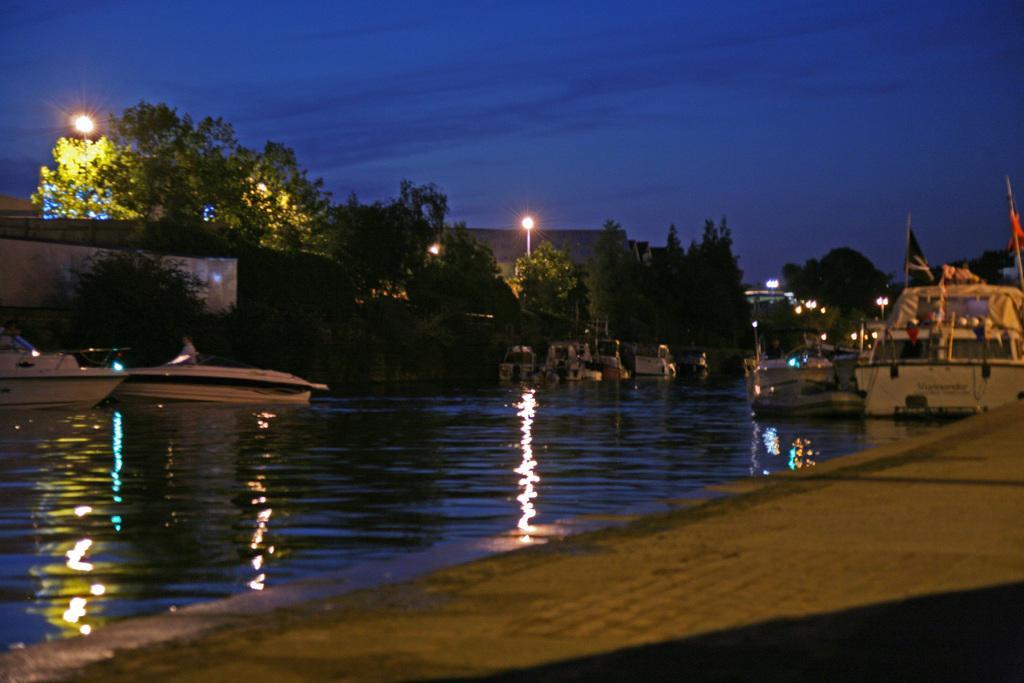Describe this image in one or two sentences. In this image we can see few boats on the water, there are few trees, lights, flags and the sky in the background. 